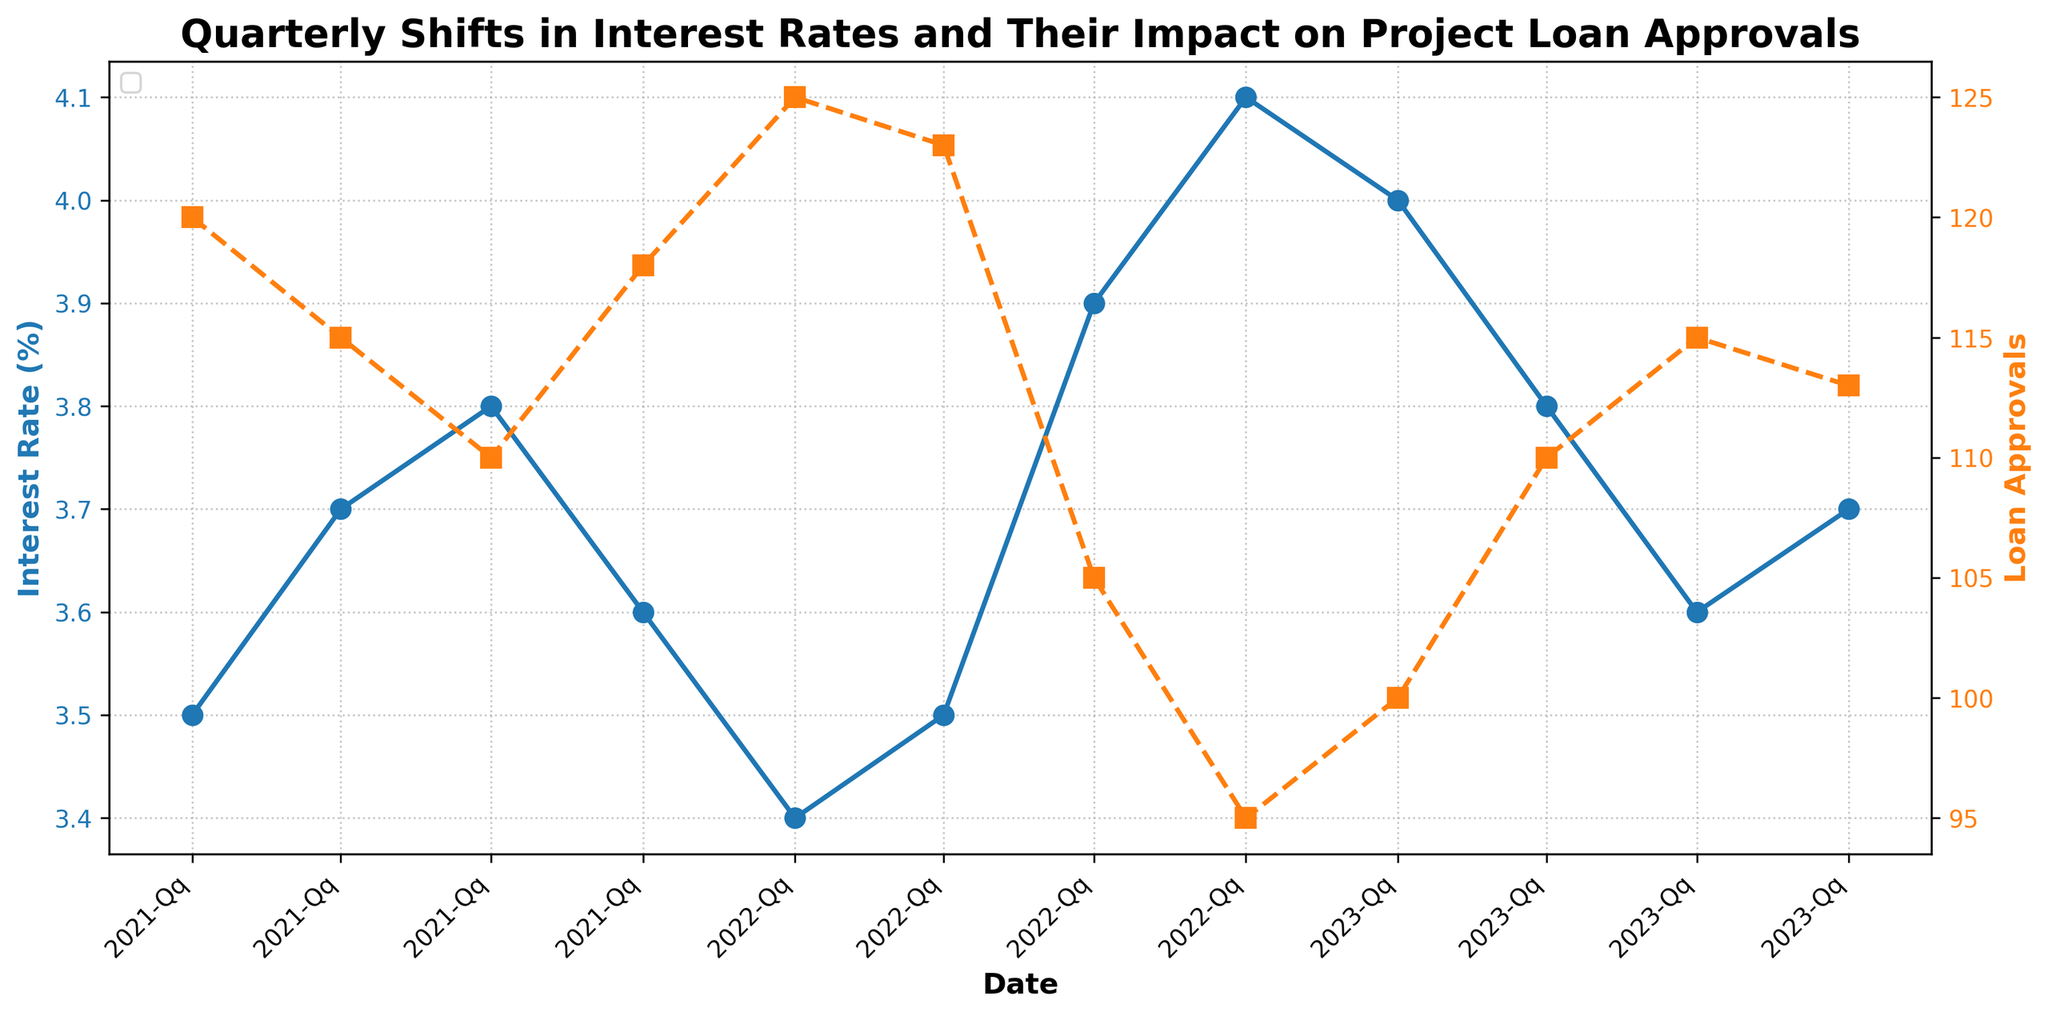What is the title of the figure? The title is displayed at the top of the figure in bold text: 'Quarterly Shifts in Interest Rates and Their Impact on Project Loan Approvals'.
Answer: Quarterly Shifts in Interest Rates and Their Impact on Project Loan Approvals What are the two variables plotted in the figure? The two variables are 'Interest Rate' and 'Loan Approvals'. The 'Interest Rate' is shown on the primary y-axis with a blue line, and 'Loan Approvals' is shown on the secondary y-axis with an orange line.
Answer: Interest Rate and Loan Approvals In which quarter was the interest rate the highest? To determine this, look at the blue line on the plot and identify the peak point. The interest rate is highest in 2022-Q4 where it reaches 4.1%.
Answer: 2022-Q4 How do loan approvals change from 2022-Q3 to 2022-Q4? Follow the orange line representing loan approvals between these two quarters. Loan approvals decreased from 105 in 2022-Q3 to 95 in 2022-Q4.
Answer: Decreased What is the range of interest rates shown in the figure? Identify the minimum and maximum values of the blue line across the entire plot. The lowest interest rate is 3.4% in 2022-Q1, and the highest is 4.1% in 2022-Q4.
Answer: 3.4% to 4.1% In which quarter did loan approvals peak? Trace the highest point on the orange line representing Loan Approvals. The peak occurs in 2022-Q1 with 125 loan approvals.
Answer: 2022-Q1 How does the interest rate in 2023-Q2 compare to 2023-Q1? Examine the blue line points for these two quarters. The interest rate decreases from 4.0% in 2023-Q1 to 3.8% in 2023-Q2.
Answer: Decreased What is the average interest rate across the entire timeframe? To find the average, sum all the interest rate values and divide by the number of data points: (3.5+3.7+3.8+3.6+3.4+3.5+3.9+4.1+4.0+3.8+3.6+3.7)/12. This calculates to (44.6/12) = 3.7167%.
Answer: 3.7167% Which quarter has the lowest number of loan approvals? Identify the lowest point on the orange line. The lowest number of loan approvals is in 2022-Q4 with 95.
Answer: 2022-Q4 How many times did the interest rate decrease consecutively? Count the instances where the blue line declines from one quarter to the next. This occurs from 2021-Q3 to 2021-Q4, from 2022-Q2 to 2022-Q1, and from 2023-Q1 to 2023-Q2, so three separate instances.
Answer: Three times 